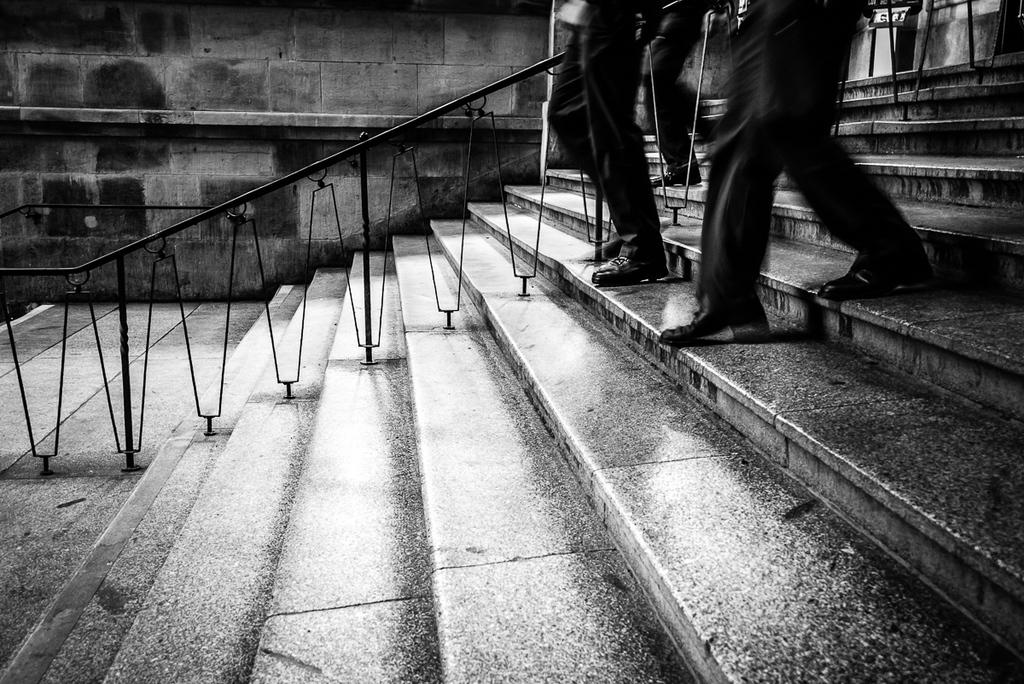What celestial objects can be seen in the image? There are stars visible in the image. What is the color of the railing in the image? The railing in the image is black. What are the persons in the image doing? There are persons walking down the stairs in the image. What is present in the background of the image? There is a wall in the background of the image. How is the image presented in terms of color? The image is black and white. What type of vessel can be seen on the sidewalk in the image? There is no vessel or sidewalk present in the image; it features stars, a black railing, persons walking down the stairs, a wall, and is presented in black and white. How long does it take for the minute hand to move in the image? There is no clock or time-related element present in the image, so it is not possible to determine the movement of a minute hand. 